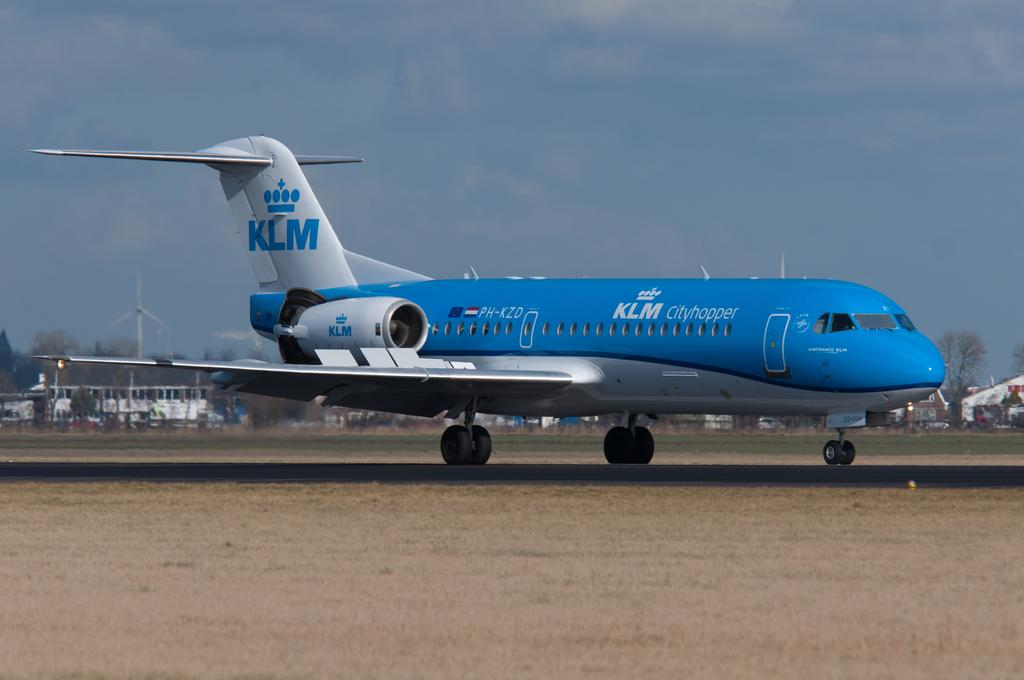<image>
Summarize the visual content of the image. A blue passenger jet that says KLM is taxiing on a runway. 